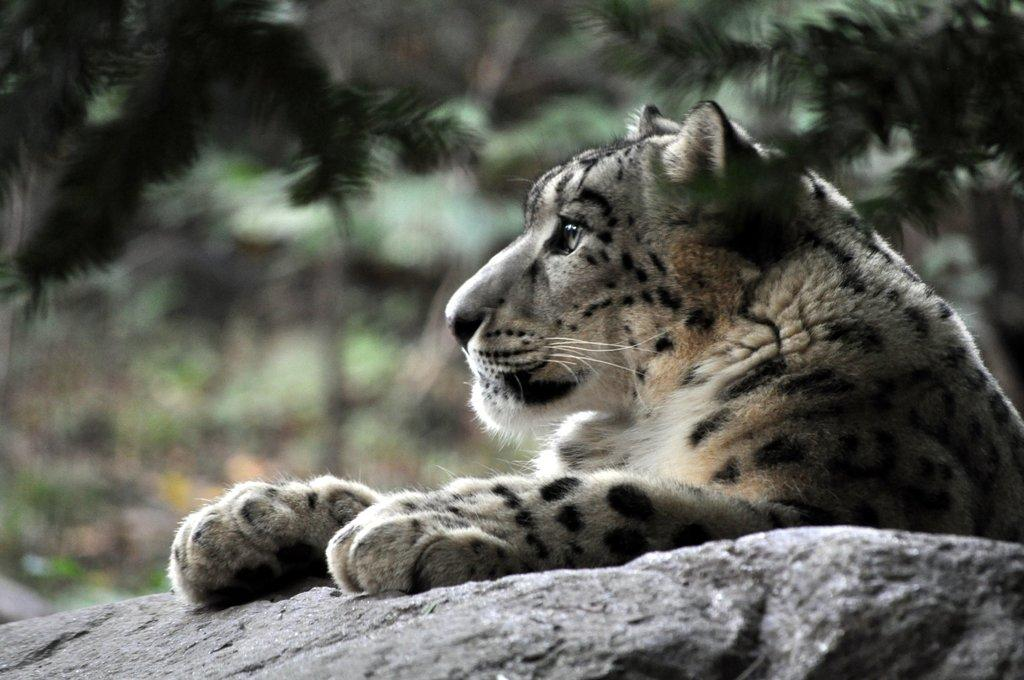What animal is the main subject of the image? There is a tiger in the image. What is the tiger doing in the image? The tiger has its hand on a stone. What can be seen in the background of the image? There are trees in the background of the image. How many girls are sitting on the seat in the image? There are no girls or seats present in the image; it features a tiger with its hand on a stone and trees in the background. 